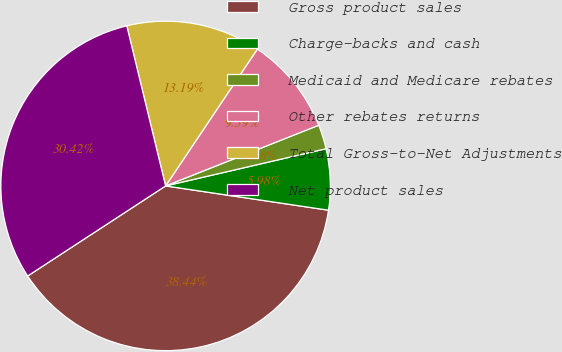Convert chart to OTSL. <chart><loc_0><loc_0><loc_500><loc_500><pie_chart><fcel>Gross product sales<fcel>Charge-backs and cash<fcel>Medicaid and Medicare rebates<fcel>Other rebates returns<fcel>Total Gross-to-Net Adjustments<fcel>Net product sales<nl><fcel>38.44%<fcel>5.98%<fcel>2.38%<fcel>9.59%<fcel>13.19%<fcel>30.42%<nl></chart> 